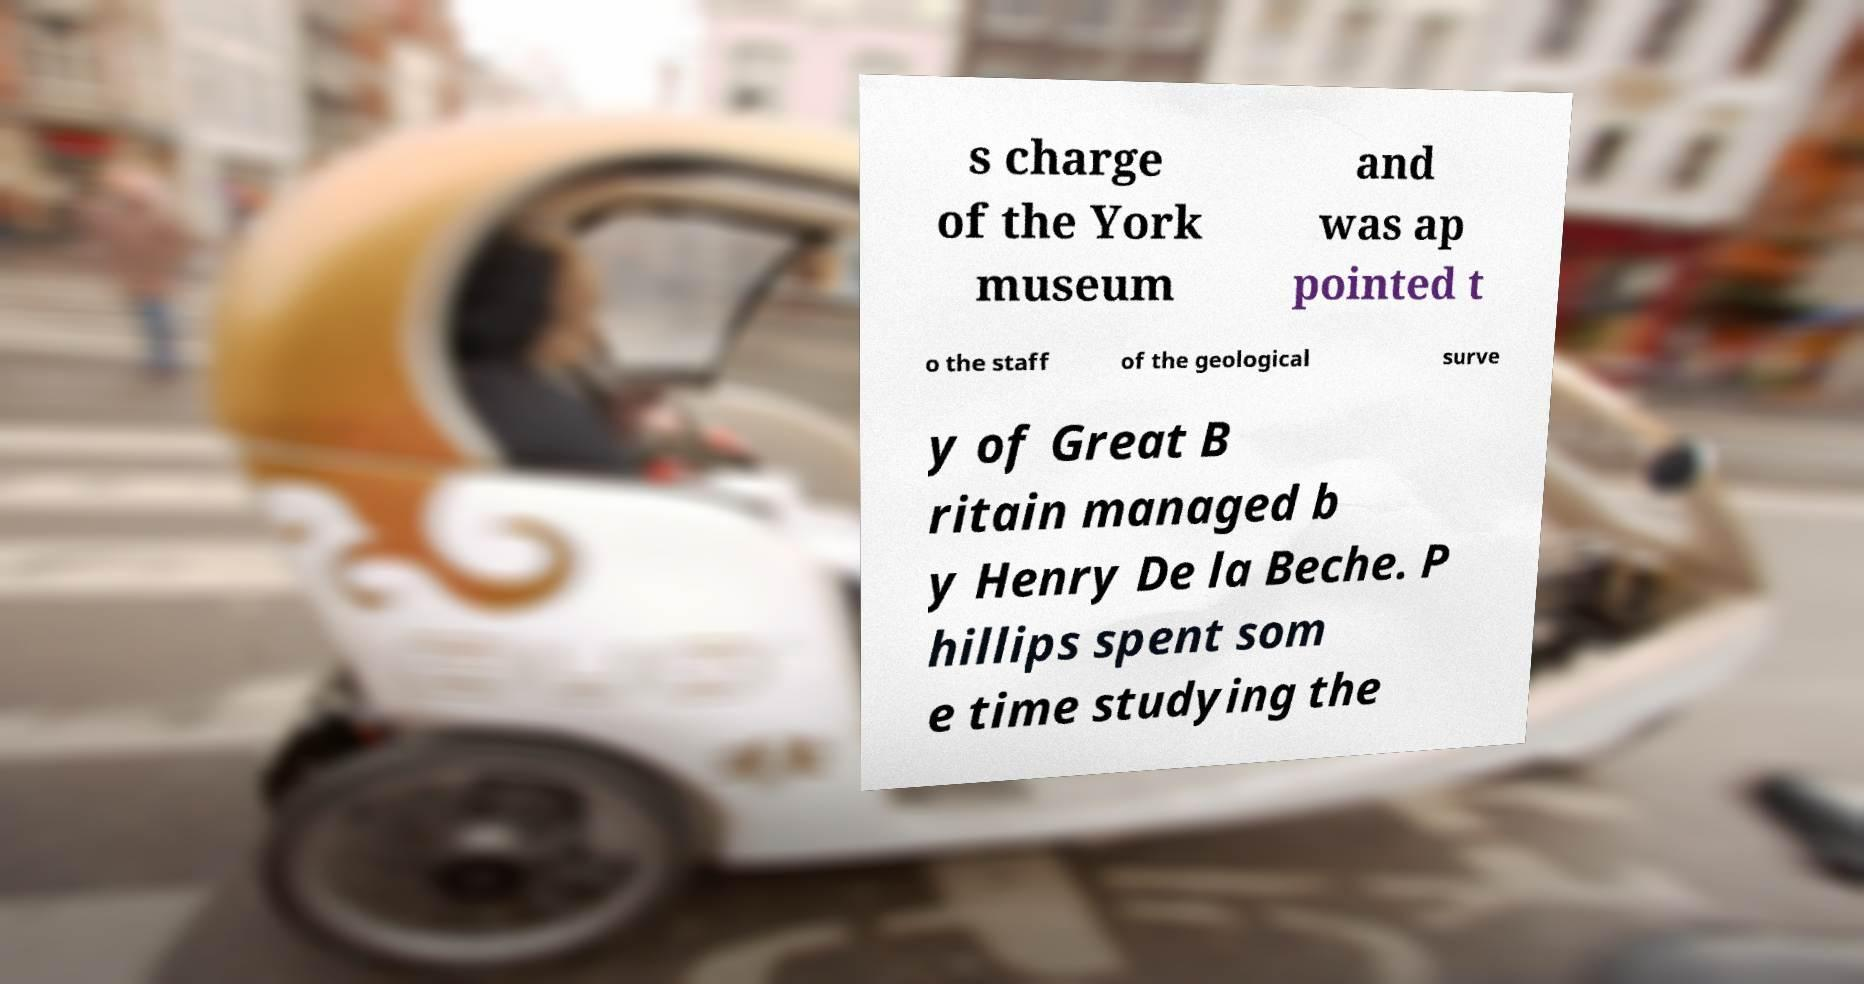Can you read and provide the text displayed in the image?This photo seems to have some interesting text. Can you extract and type it out for me? s charge of the York museum and was ap pointed t o the staff of the geological surve y of Great B ritain managed b y Henry De la Beche. P hillips spent som e time studying the 